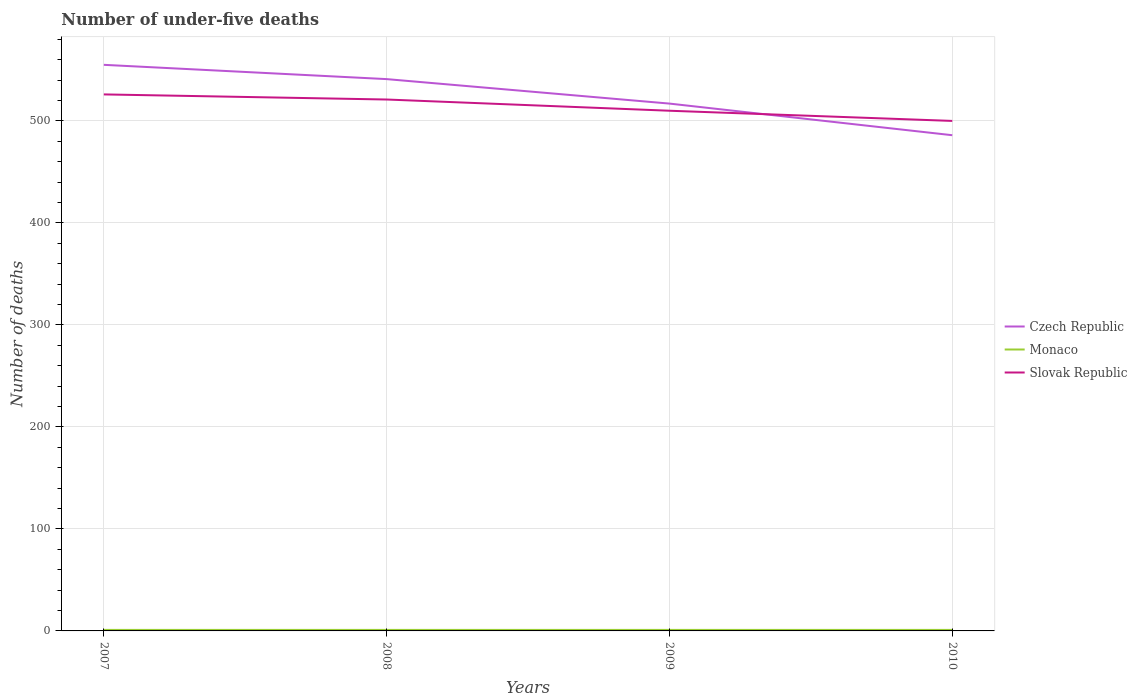Is the number of lines equal to the number of legend labels?
Offer a very short reply. Yes. Across all years, what is the maximum number of under-five deaths in Czech Republic?
Your answer should be compact. 486. In which year was the number of under-five deaths in Monaco maximum?
Offer a very short reply. 2007. What is the total number of under-five deaths in Slovak Republic in the graph?
Ensure brevity in your answer.  10. Is the number of under-five deaths in Monaco strictly greater than the number of under-five deaths in Slovak Republic over the years?
Your answer should be very brief. Yes. How many lines are there?
Your response must be concise. 3. How many years are there in the graph?
Offer a terse response. 4. What is the difference between two consecutive major ticks on the Y-axis?
Give a very brief answer. 100. Are the values on the major ticks of Y-axis written in scientific E-notation?
Provide a succinct answer. No. Does the graph contain grids?
Provide a succinct answer. Yes. What is the title of the graph?
Make the answer very short. Number of under-five deaths. Does "Upper middle income" appear as one of the legend labels in the graph?
Keep it short and to the point. No. What is the label or title of the X-axis?
Offer a very short reply. Years. What is the label or title of the Y-axis?
Offer a very short reply. Number of deaths. What is the Number of deaths of Czech Republic in 2007?
Make the answer very short. 555. What is the Number of deaths in Monaco in 2007?
Your answer should be compact. 1. What is the Number of deaths of Slovak Republic in 2007?
Keep it short and to the point. 526. What is the Number of deaths in Czech Republic in 2008?
Ensure brevity in your answer.  541. What is the Number of deaths of Monaco in 2008?
Keep it short and to the point. 1. What is the Number of deaths in Slovak Republic in 2008?
Provide a succinct answer. 521. What is the Number of deaths of Czech Republic in 2009?
Your answer should be very brief. 517. What is the Number of deaths in Slovak Republic in 2009?
Your response must be concise. 510. What is the Number of deaths of Czech Republic in 2010?
Make the answer very short. 486. Across all years, what is the maximum Number of deaths of Czech Republic?
Offer a very short reply. 555. Across all years, what is the maximum Number of deaths in Slovak Republic?
Offer a very short reply. 526. Across all years, what is the minimum Number of deaths in Czech Republic?
Provide a succinct answer. 486. What is the total Number of deaths in Czech Republic in the graph?
Ensure brevity in your answer.  2099. What is the total Number of deaths in Monaco in the graph?
Provide a succinct answer. 4. What is the total Number of deaths in Slovak Republic in the graph?
Your answer should be very brief. 2057. What is the difference between the Number of deaths in Czech Republic in 2007 and that in 2008?
Keep it short and to the point. 14. What is the difference between the Number of deaths of Slovak Republic in 2007 and that in 2008?
Your answer should be compact. 5. What is the difference between the Number of deaths in Czech Republic in 2007 and that in 2009?
Offer a terse response. 38. What is the difference between the Number of deaths in Monaco in 2007 and that in 2009?
Offer a terse response. 0. What is the difference between the Number of deaths in Slovak Republic in 2007 and that in 2009?
Ensure brevity in your answer.  16. What is the difference between the Number of deaths of Monaco in 2008 and that in 2009?
Keep it short and to the point. 0. What is the difference between the Number of deaths of Slovak Republic in 2008 and that in 2009?
Your answer should be very brief. 11. What is the difference between the Number of deaths of Czech Republic in 2009 and that in 2010?
Keep it short and to the point. 31. What is the difference between the Number of deaths of Slovak Republic in 2009 and that in 2010?
Your answer should be very brief. 10. What is the difference between the Number of deaths of Czech Republic in 2007 and the Number of deaths of Monaco in 2008?
Your answer should be compact. 554. What is the difference between the Number of deaths in Czech Republic in 2007 and the Number of deaths in Slovak Republic in 2008?
Provide a succinct answer. 34. What is the difference between the Number of deaths in Monaco in 2007 and the Number of deaths in Slovak Republic in 2008?
Provide a succinct answer. -520. What is the difference between the Number of deaths in Czech Republic in 2007 and the Number of deaths in Monaco in 2009?
Your answer should be compact. 554. What is the difference between the Number of deaths in Czech Republic in 2007 and the Number of deaths in Slovak Republic in 2009?
Provide a short and direct response. 45. What is the difference between the Number of deaths of Monaco in 2007 and the Number of deaths of Slovak Republic in 2009?
Offer a very short reply. -509. What is the difference between the Number of deaths of Czech Republic in 2007 and the Number of deaths of Monaco in 2010?
Give a very brief answer. 554. What is the difference between the Number of deaths of Czech Republic in 2007 and the Number of deaths of Slovak Republic in 2010?
Offer a very short reply. 55. What is the difference between the Number of deaths of Monaco in 2007 and the Number of deaths of Slovak Republic in 2010?
Give a very brief answer. -499. What is the difference between the Number of deaths in Czech Republic in 2008 and the Number of deaths in Monaco in 2009?
Keep it short and to the point. 540. What is the difference between the Number of deaths of Monaco in 2008 and the Number of deaths of Slovak Republic in 2009?
Keep it short and to the point. -509. What is the difference between the Number of deaths of Czech Republic in 2008 and the Number of deaths of Monaco in 2010?
Give a very brief answer. 540. What is the difference between the Number of deaths of Czech Republic in 2008 and the Number of deaths of Slovak Republic in 2010?
Provide a short and direct response. 41. What is the difference between the Number of deaths of Monaco in 2008 and the Number of deaths of Slovak Republic in 2010?
Offer a terse response. -499. What is the difference between the Number of deaths in Czech Republic in 2009 and the Number of deaths in Monaco in 2010?
Your response must be concise. 516. What is the difference between the Number of deaths in Czech Republic in 2009 and the Number of deaths in Slovak Republic in 2010?
Give a very brief answer. 17. What is the difference between the Number of deaths in Monaco in 2009 and the Number of deaths in Slovak Republic in 2010?
Offer a terse response. -499. What is the average Number of deaths of Czech Republic per year?
Offer a terse response. 524.75. What is the average Number of deaths of Slovak Republic per year?
Your answer should be compact. 514.25. In the year 2007, what is the difference between the Number of deaths in Czech Republic and Number of deaths in Monaco?
Offer a very short reply. 554. In the year 2007, what is the difference between the Number of deaths in Monaco and Number of deaths in Slovak Republic?
Give a very brief answer. -525. In the year 2008, what is the difference between the Number of deaths of Czech Republic and Number of deaths of Monaco?
Make the answer very short. 540. In the year 2008, what is the difference between the Number of deaths in Monaco and Number of deaths in Slovak Republic?
Give a very brief answer. -520. In the year 2009, what is the difference between the Number of deaths in Czech Republic and Number of deaths in Monaco?
Ensure brevity in your answer.  516. In the year 2009, what is the difference between the Number of deaths of Czech Republic and Number of deaths of Slovak Republic?
Your answer should be compact. 7. In the year 2009, what is the difference between the Number of deaths of Monaco and Number of deaths of Slovak Republic?
Provide a short and direct response. -509. In the year 2010, what is the difference between the Number of deaths of Czech Republic and Number of deaths of Monaco?
Your response must be concise. 485. In the year 2010, what is the difference between the Number of deaths in Czech Republic and Number of deaths in Slovak Republic?
Your answer should be very brief. -14. In the year 2010, what is the difference between the Number of deaths of Monaco and Number of deaths of Slovak Republic?
Ensure brevity in your answer.  -499. What is the ratio of the Number of deaths of Czech Republic in 2007 to that in 2008?
Your response must be concise. 1.03. What is the ratio of the Number of deaths of Monaco in 2007 to that in 2008?
Your answer should be compact. 1. What is the ratio of the Number of deaths in Slovak Republic in 2007 to that in 2008?
Your answer should be very brief. 1.01. What is the ratio of the Number of deaths of Czech Republic in 2007 to that in 2009?
Your response must be concise. 1.07. What is the ratio of the Number of deaths in Slovak Republic in 2007 to that in 2009?
Provide a short and direct response. 1.03. What is the ratio of the Number of deaths in Czech Republic in 2007 to that in 2010?
Your answer should be compact. 1.14. What is the ratio of the Number of deaths of Slovak Republic in 2007 to that in 2010?
Make the answer very short. 1.05. What is the ratio of the Number of deaths in Czech Republic in 2008 to that in 2009?
Offer a very short reply. 1.05. What is the ratio of the Number of deaths of Slovak Republic in 2008 to that in 2009?
Your answer should be compact. 1.02. What is the ratio of the Number of deaths in Czech Republic in 2008 to that in 2010?
Make the answer very short. 1.11. What is the ratio of the Number of deaths in Slovak Republic in 2008 to that in 2010?
Make the answer very short. 1.04. What is the ratio of the Number of deaths of Czech Republic in 2009 to that in 2010?
Give a very brief answer. 1.06. What is the ratio of the Number of deaths in Monaco in 2009 to that in 2010?
Your response must be concise. 1. What is the difference between the highest and the second highest Number of deaths in Czech Republic?
Ensure brevity in your answer.  14. What is the difference between the highest and the second highest Number of deaths of Monaco?
Your response must be concise. 0. What is the difference between the highest and the lowest Number of deaths of Czech Republic?
Your answer should be compact. 69. What is the difference between the highest and the lowest Number of deaths of Monaco?
Provide a short and direct response. 0. 